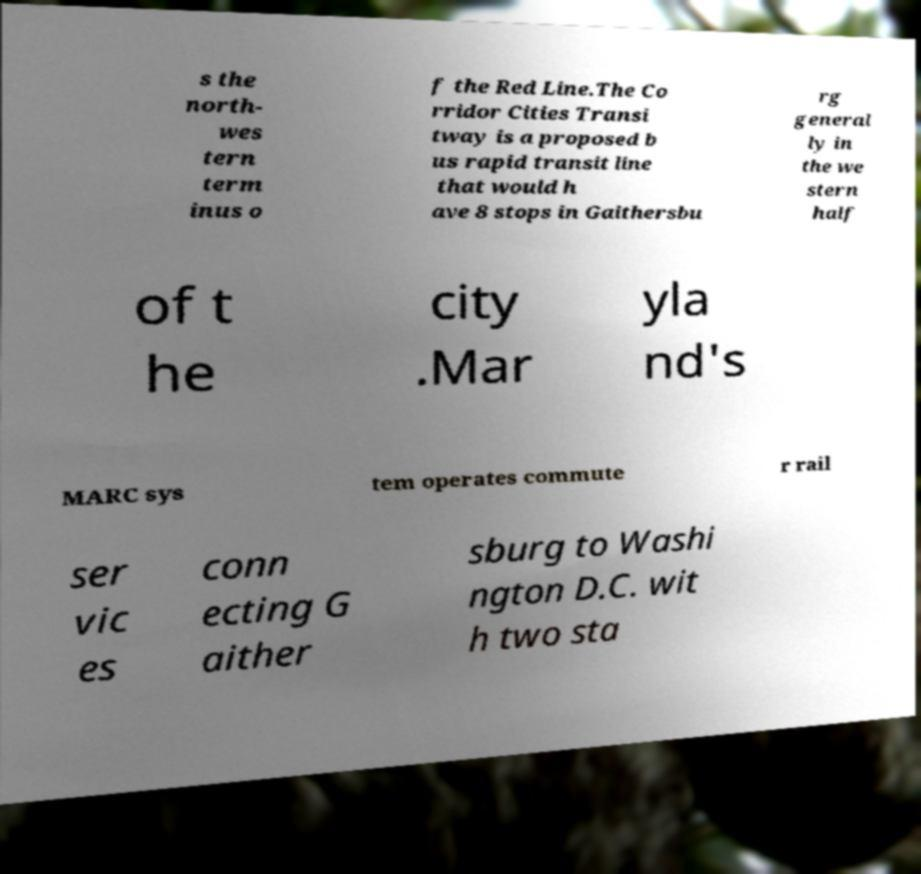Could you extract and type out the text from this image? s the north- wes tern term inus o f the Red Line.The Co rridor Cities Transi tway is a proposed b us rapid transit line that would h ave 8 stops in Gaithersbu rg general ly in the we stern half of t he city .Mar yla nd's MARC sys tem operates commute r rail ser vic es conn ecting G aither sburg to Washi ngton D.C. wit h two sta 